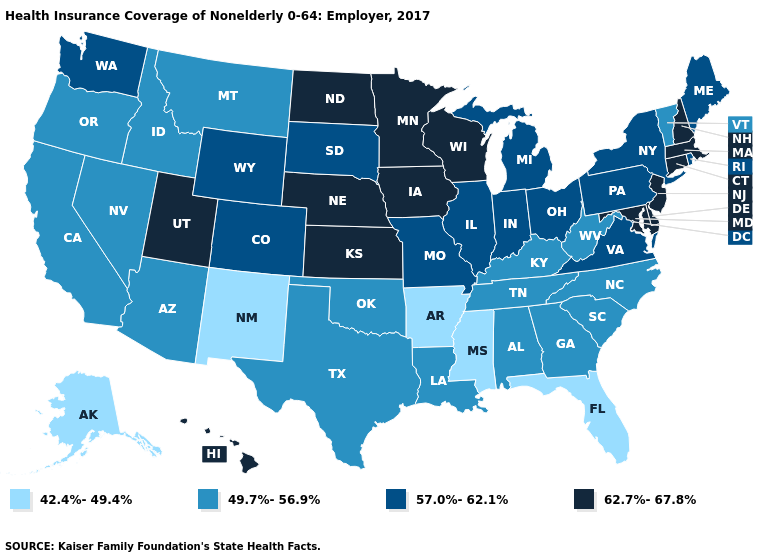Which states have the lowest value in the USA?
Give a very brief answer. Alaska, Arkansas, Florida, Mississippi, New Mexico. What is the value of North Dakota?
Answer briefly. 62.7%-67.8%. Does Texas have the lowest value in the South?
Be succinct. No. Does the map have missing data?
Write a very short answer. No. Does the map have missing data?
Quick response, please. No. What is the value of Mississippi?
Write a very short answer. 42.4%-49.4%. Among the states that border Michigan , does Ohio have the lowest value?
Write a very short answer. Yes. Among the states that border West Virginia , does Ohio have the lowest value?
Give a very brief answer. No. Which states hav the highest value in the South?
Answer briefly. Delaware, Maryland. Does Louisiana have a lower value than Arkansas?
Give a very brief answer. No. What is the value of Florida?
Write a very short answer. 42.4%-49.4%. What is the value of Pennsylvania?
Concise answer only. 57.0%-62.1%. Name the states that have a value in the range 57.0%-62.1%?
Concise answer only. Colorado, Illinois, Indiana, Maine, Michigan, Missouri, New York, Ohio, Pennsylvania, Rhode Island, South Dakota, Virginia, Washington, Wyoming. 